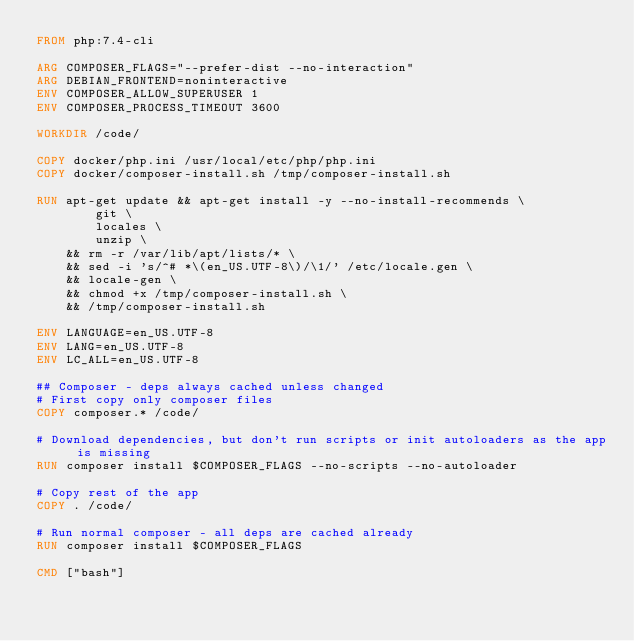Convert code to text. <code><loc_0><loc_0><loc_500><loc_500><_Dockerfile_>FROM php:7.4-cli

ARG COMPOSER_FLAGS="--prefer-dist --no-interaction"
ARG DEBIAN_FRONTEND=noninteractive
ENV COMPOSER_ALLOW_SUPERUSER 1
ENV COMPOSER_PROCESS_TIMEOUT 3600

WORKDIR /code/

COPY docker/php.ini /usr/local/etc/php/php.ini
COPY docker/composer-install.sh /tmp/composer-install.sh

RUN apt-get update && apt-get install -y --no-install-recommends \
        git \
        locales \
        unzip \
	&& rm -r /var/lib/apt/lists/* \
	&& sed -i 's/^# *\(en_US.UTF-8\)/\1/' /etc/locale.gen \
	&& locale-gen \
	&& chmod +x /tmp/composer-install.sh \
	&& /tmp/composer-install.sh

ENV LANGUAGE=en_US.UTF-8
ENV LANG=en_US.UTF-8
ENV LC_ALL=en_US.UTF-8

## Composer - deps always cached unless changed
# First copy only composer files
COPY composer.* /code/

# Download dependencies, but don't run scripts or init autoloaders as the app is missing
RUN composer install $COMPOSER_FLAGS --no-scripts --no-autoloader

# Copy rest of the app
COPY . /code/

# Run normal composer - all deps are cached already
RUN composer install $COMPOSER_FLAGS

CMD ["bash"]
</code> 